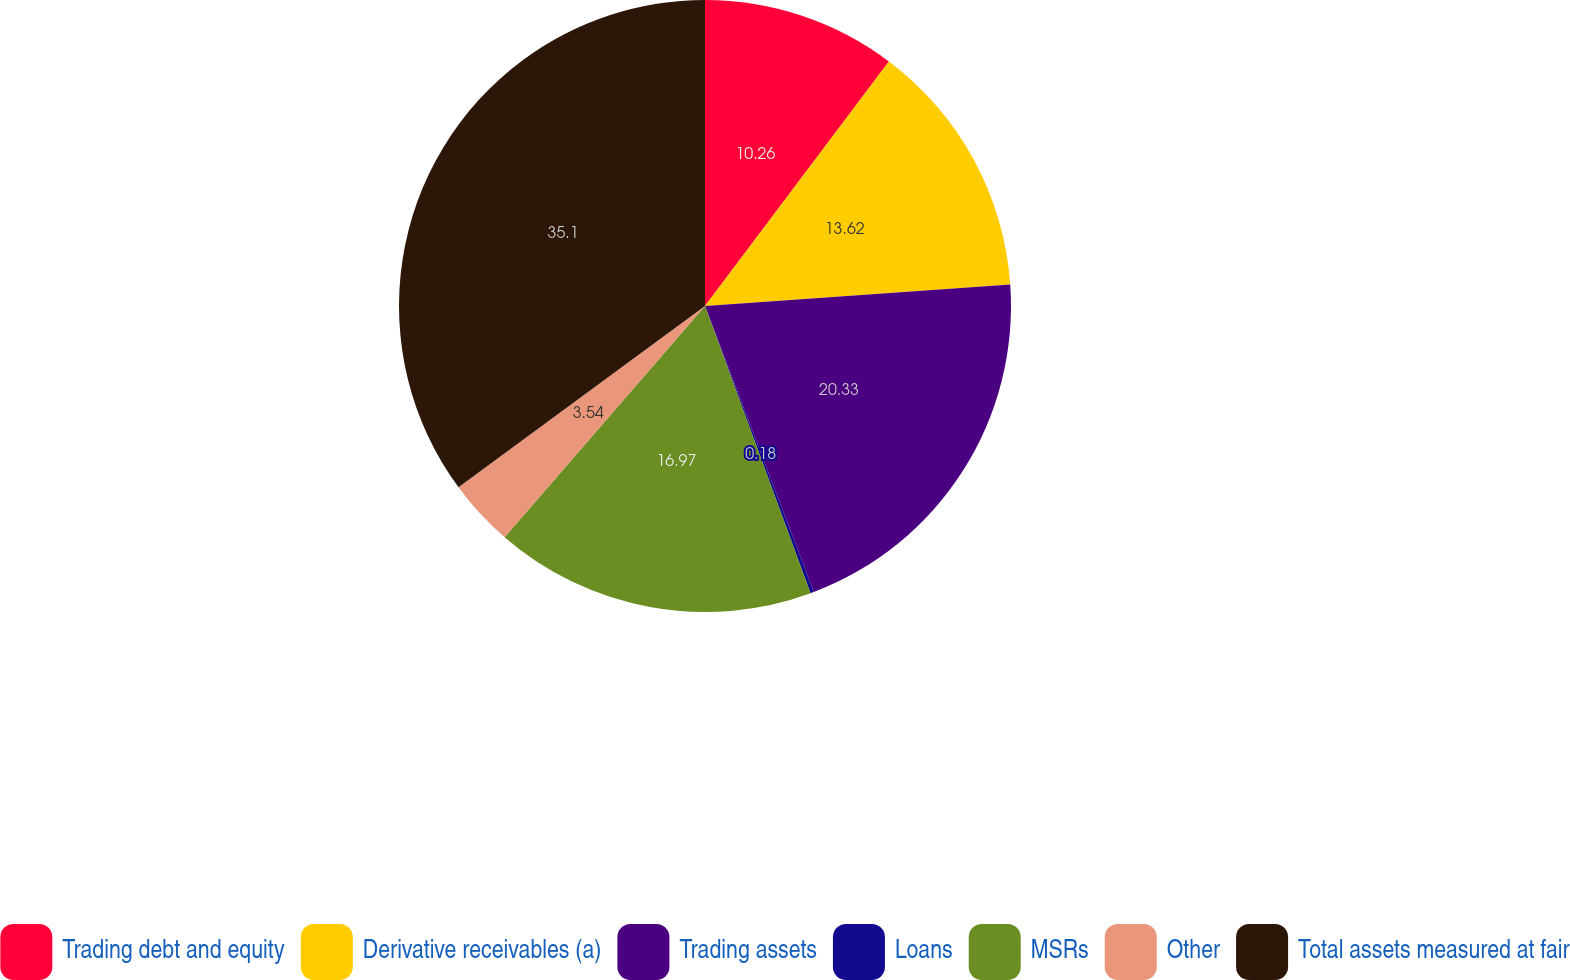Convert chart. <chart><loc_0><loc_0><loc_500><loc_500><pie_chart><fcel>Trading debt and equity<fcel>Derivative receivables (a)<fcel>Trading assets<fcel>Loans<fcel>MSRs<fcel>Other<fcel>Total assets measured at fair<nl><fcel>10.26%<fcel>13.62%<fcel>20.33%<fcel>0.18%<fcel>16.97%<fcel>3.54%<fcel>35.09%<nl></chart> 